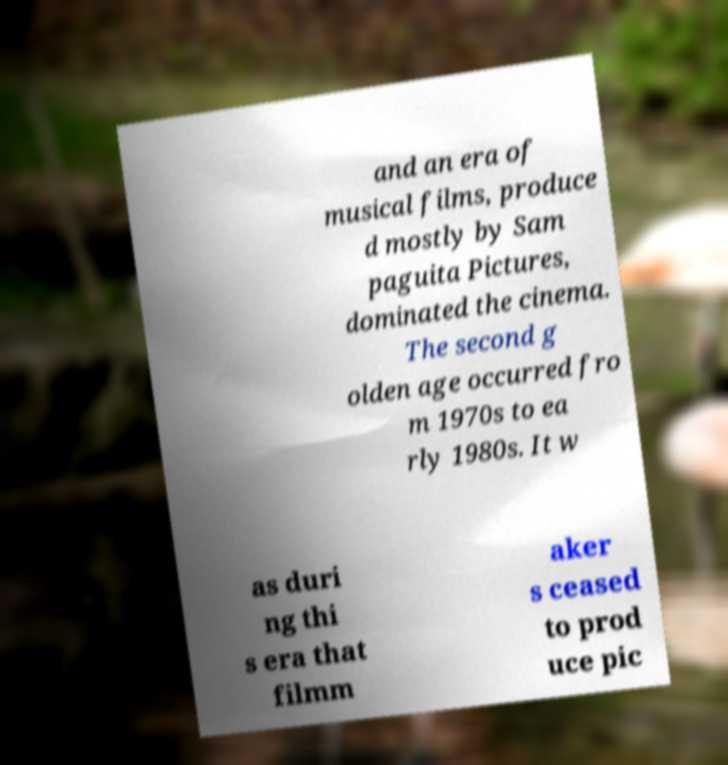What messages or text are displayed in this image? I need them in a readable, typed format. and an era of musical films, produce d mostly by Sam paguita Pictures, dominated the cinema. The second g olden age occurred fro m 1970s to ea rly 1980s. It w as duri ng thi s era that filmm aker s ceased to prod uce pic 